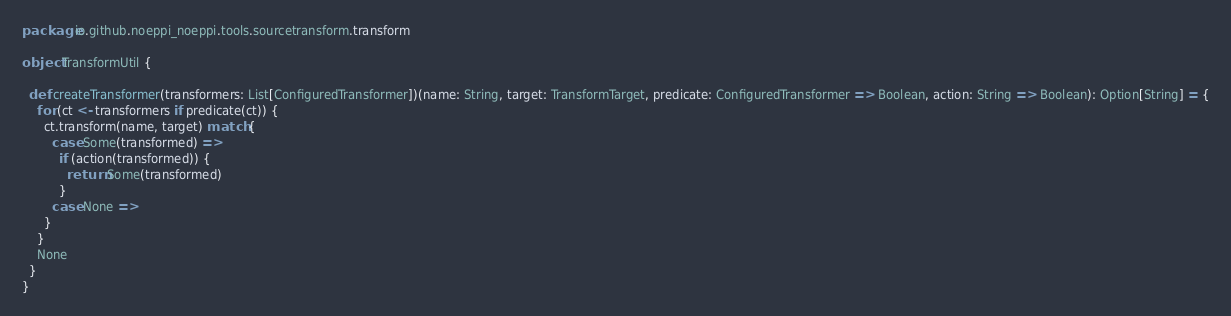Convert code to text. <code><loc_0><loc_0><loc_500><loc_500><_Scala_>package io.github.noeppi_noeppi.tools.sourcetransform.transform

object TransformUtil {

  def createTransformer(transformers: List[ConfiguredTransformer])(name: String, target: TransformTarget, predicate: ConfiguredTransformer => Boolean, action: String => Boolean): Option[String] = {
    for (ct <- transformers if predicate(ct)) {
      ct.transform(name, target) match {
        case Some(transformed) =>
          if (action(transformed)) {
            return Some(transformed)
          }
        case None =>
      }
    }
    None
  }
}
</code> 